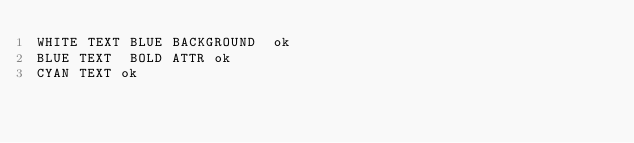Convert code to text. <code><loc_0><loc_0><loc_500><loc_500><_Forth_>WHITE TEXT BLUE BACKGROUND  ok
BLUE TEXT  BOLD ATTR ok
CYAN TEXT ok
</code> 